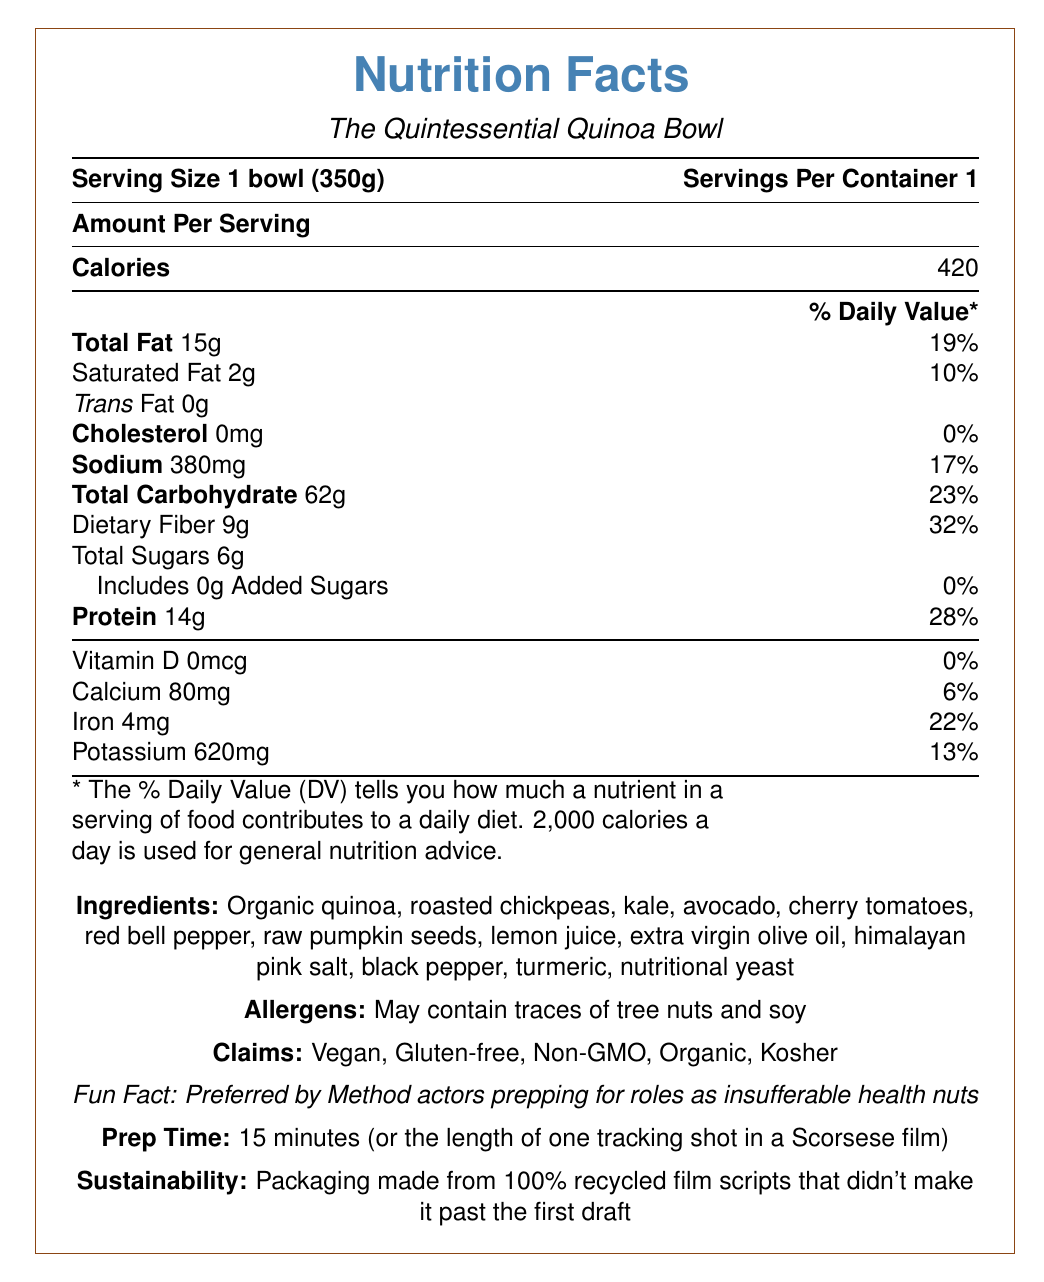what is the serving size? The serving size is indicated at the top of the document as "Serving Size: 1 bowl (350g)".
Answer: 1 bowl (350g) how much total fat is in one serving? The amount of total fat per serving is listed as "Total Fat 15g” under the nutrition facts.
Answer: 15g what is the daily value percentage for protein? The percentage of daily value for protein is shown as "Protein 14g" with 28% daily value.
Answer: 28% are there any added sugars in the quinoa bowl? The document states "Includes 0g Added Sugars" under the total sugars section.
Answer: No which nutrient has the highest percentage of daily value? The document lists Dietary Fiber at 32% daily value, which is the highest among the listed nutrients.
Answer: Dietary Fiber what claims are made about this quinoa bowl? A. Vegan B. Non-GMO C. Kosher D. All of the above The claims section lists the quinoa bowl as "Vegan", "Non-GMO", and "Kosher" among other claims, making option D the correct answer.
Answer: D how much calcium do you get from one serving? Under the vitamins and minerals section, the document lists "Calcium 80mg".
Answer: 80mg which ingredient is NOT in the quinoa bowl? A. Roasted chickpeas B. Avocado C. Brown rice D. Lemon juice The listed ingredients include "Roasted chickpeas," "Avocado," and "Lemon juice" but do not mention brown rice.
Answer: C is this quinoa bowl gluten-free? The claims section clearly lists "Gluten-free" as one of the claims.
Answer: Yes summarize the entire document The document provides detailed nutrition facts for a vegan, gluten-free quinoa bowl weighing 350g per serving. It highlights the calories, macronutrients, vitamins, and minerals. The bowl contains ingredients like organic quinoa, roasted chickpeas, and avocado. Claims include being vegan, gluten-free, non-GMO, organic, and kosher. Fun facts and sustainability information add a playful touch. what is the prep time for the quinoa bowl? The prep time is indicated as "15 minutes (or the length of one tracking shot in a Scorsese film)".
Answer: 15 minutes how many servings per container are there? The document lists "Servings Per Container: 1" right at the top.
Answer: 1 can I determine the exact preparation method for the ingredients? The document lists the prep time but does not provide step-by-step preparation instructions.
Answer: Not enough information how much sodium is in one serving of the quinoa bowl? The sodium content is listed as "Sodium 380mg" in the nutrition facts section.
Answer: 380mg does this product contain dairy? The ingredients list shows no dairy items, and the claims also state the product is vegan, which excludes dairy.
Answer: No 